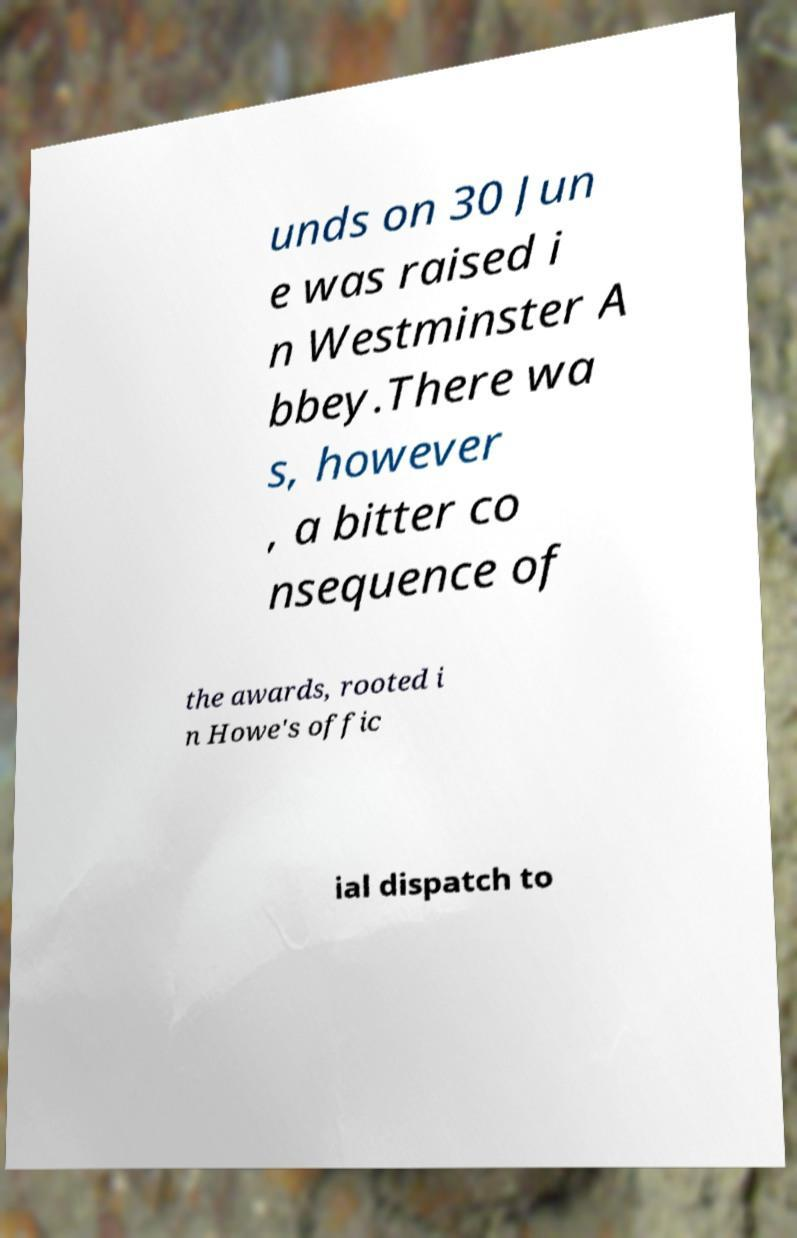Can you accurately transcribe the text from the provided image for me? unds on 30 Jun e was raised i n Westminster A bbey.There wa s, however , a bitter co nsequence of the awards, rooted i n Howe's offic ial dispatch to 